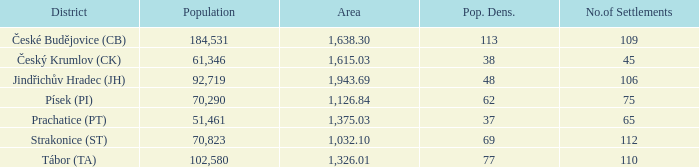Would you mind parsing the complete table? {'header': ['District', 'Population', 'Area', 'Pop. Dens.', 'No.of Settlements'], 'rows': [['České Budějovice (CB)', '184,531', '1,638.30', '113', '109'], ['Český Krumlov (CK)', '61,346', '1,615.03', '38', '45'], ['Jindřichův Hradec (JH)', '92,719', '1,943.69', '48', '106'], ['Písek (PI)', '70,290', '1,126.84', '62', '75'], ['Prachatice (PT)', '51,461', '1,375.03', '37', '65'], ['Strakonice (ST)', '70,823', '1,032.10', '69', '112'], ['Tábor (TA)', '102,580', '1,326.01', '77', '110']]} What is the population with an area of 1,126.84? 70290.0. 